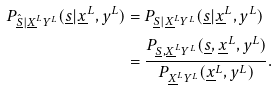<formula> <loc_0><loc_0><loc_500><loc_500>P _ { \hat { \underline { S } } | \underline { X } ^ { L } Y ^ { L } } ( { \underline { s } } | \underline { x } ^ { L } , y ^ { L } ) & = P _ { { \underline { S } } | \underline { X } ^ { L } Y ^ { L } } ( { \underline { s } } | \underline { x } ^ { L } , y ^ { L } ) \\ & = \frac { P _ { { \underline { S } } , \underline { X } ^ { L } Y ^ { L } } ( { \underline { s } } , \underline { x } ^ { L } , y ^ { L } ) } { P _ { \underline { X } ^ { L } Y ^ { L } } ( \underline { x } ^ { L } , y ^ { L } ) } .</formula> 